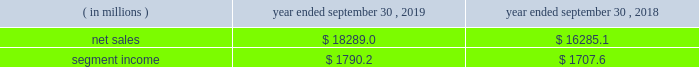Containerboard , kraft papers and saturating kraft .
Kapstone also owns victory packaging , a packaging solutions distribution company with facilities in the u.s. , canada and mexico .
We have included the financial results of kapstone in our corrugated packaging segment since the date of the acquisition .
On september 4 , 2018 , we completed the acquisition ( the 201cschl fcter acquisition 201d ) of schl fcter print pharma packaging ( 201cschl fcter 201d ) .
Schl fcter is a leading provider of differentiated paper and packaging solutions and a german-based supplier of a full range of leaflets and booklets .
The schl fcter acquisition allowed us to further enhance our pharmaceutical and automotive platform and expand our geographical footprint in europe to better serve our customers .
We have included the financial results of the acquired operations in our consumer packaging segment since the date of the acquisition .
On january 5 , 2018 , we completed the acquisition ( the 201cplymouth packaging acquisition 201d ) of substantially all of the assets of plymouth packaging , inc .
( 201cplymouth 201d ) .
The assets we acquired included plymouth 2019s 201cbox on demand 201d systems , which are manufactured by panotec , an italian manufacturer of packaging machines .
The addition of the box on demand systems enhanced our platform , differentiation and innovation .
These systems , which are located on customers 2019 sites under multi-year exclusive agreements , use fanfold corrugated to produce custom , on-demand corrugated packaging that is accurately sized for any product type according to the customer 2019s specifications .
Fanfold corrugated is continuous corrugated board , folded periodically to form an accordion-like stack of corrugated material .
As part of the transaction , westrock acquired plymouth 2019s equity interest in panotec and plymouth 2019s exclusive right from panotec to distribute panotec 2019s equipment in the u.s .
And canada .
We have fully integrated the approximately 60000 tons of containerboard used by plymouth annually .
We have included the financial results of plymouth in our corrugated packaging segment since the date of the acquisition .
See 201cnote 3 .
Acquisitions and investment 201d of the notes to consolidated financial statements for additional information .
See also item 1a .
201crisk factors 2014 we may be unsuccessful in making and integrating mergers , acquisitions and investments , and completing divestitures 201d .
Business .
In fiscal 2019 , we continued to pursue our strategy of offering differentiated paper and packaging solutions that help our customers win .
We successfully executed this strategy in fiscal 2019 in a rapidly changing cost and price environment .
Net sales of $ 18289.0 million for fiscal 2019 increased $ 2003.9 million , or 12.3% ( 12.3 % ) , compared to fiscal 2018 .
The increase was primarily due to the kapstone acquisition and higher selling price/mix in our corrugated packaging and consumer packaging segments .
These increases were partially offset by the absence of recycling net sales in fiscal 2019 as a result of conducting the operations primarily as a procurement function beginning in the first quarter of fiscal 2019 , lower volumes , unfavorable foreign currency impacts across our segments compared to the prior year and decreased land and development net sales .
Segment income increased $ 82.6 million in fiscal 2019 compared to fiscal 2018 , primarily due to increased corrugated packaging segment income that was partially offset by lower consumer packaging and land and development segment income .
The impact of the contribution from the acquired kapstone operations , higher selling price/mix across our segments and productivity improvements was largely offset by lower volumes across our segments , economic downtime , cost inflation , increased maintenance and scheduled strategic outage expense ( including projects at our mahrt , al and covington , va mills ) and lower land and development segment income due to the wind-down of sales .
With respect to segment income , we experienced higher levels of cost inflation in both our corrugated packaging and consumer packaging segments during fiscal 2019 as compared to fiscal 2018 that were partially offset by recovered fiber deflation .
The primary inflationary items were virgin fiber , freight , energy and wage and other costs .
We generated $ 2310.2 million of net cash provided by operating activities in fiscal 2019 , compared to $ 1931.2 million in fiscal 2018 .
We remained committed to our disciplined capital allocation strategy during fiscal .
What was the percentage change in the segment income? 
Computations: ((1790.2 - 1707.6) / 1707.6)
Answer: 0.04837. 